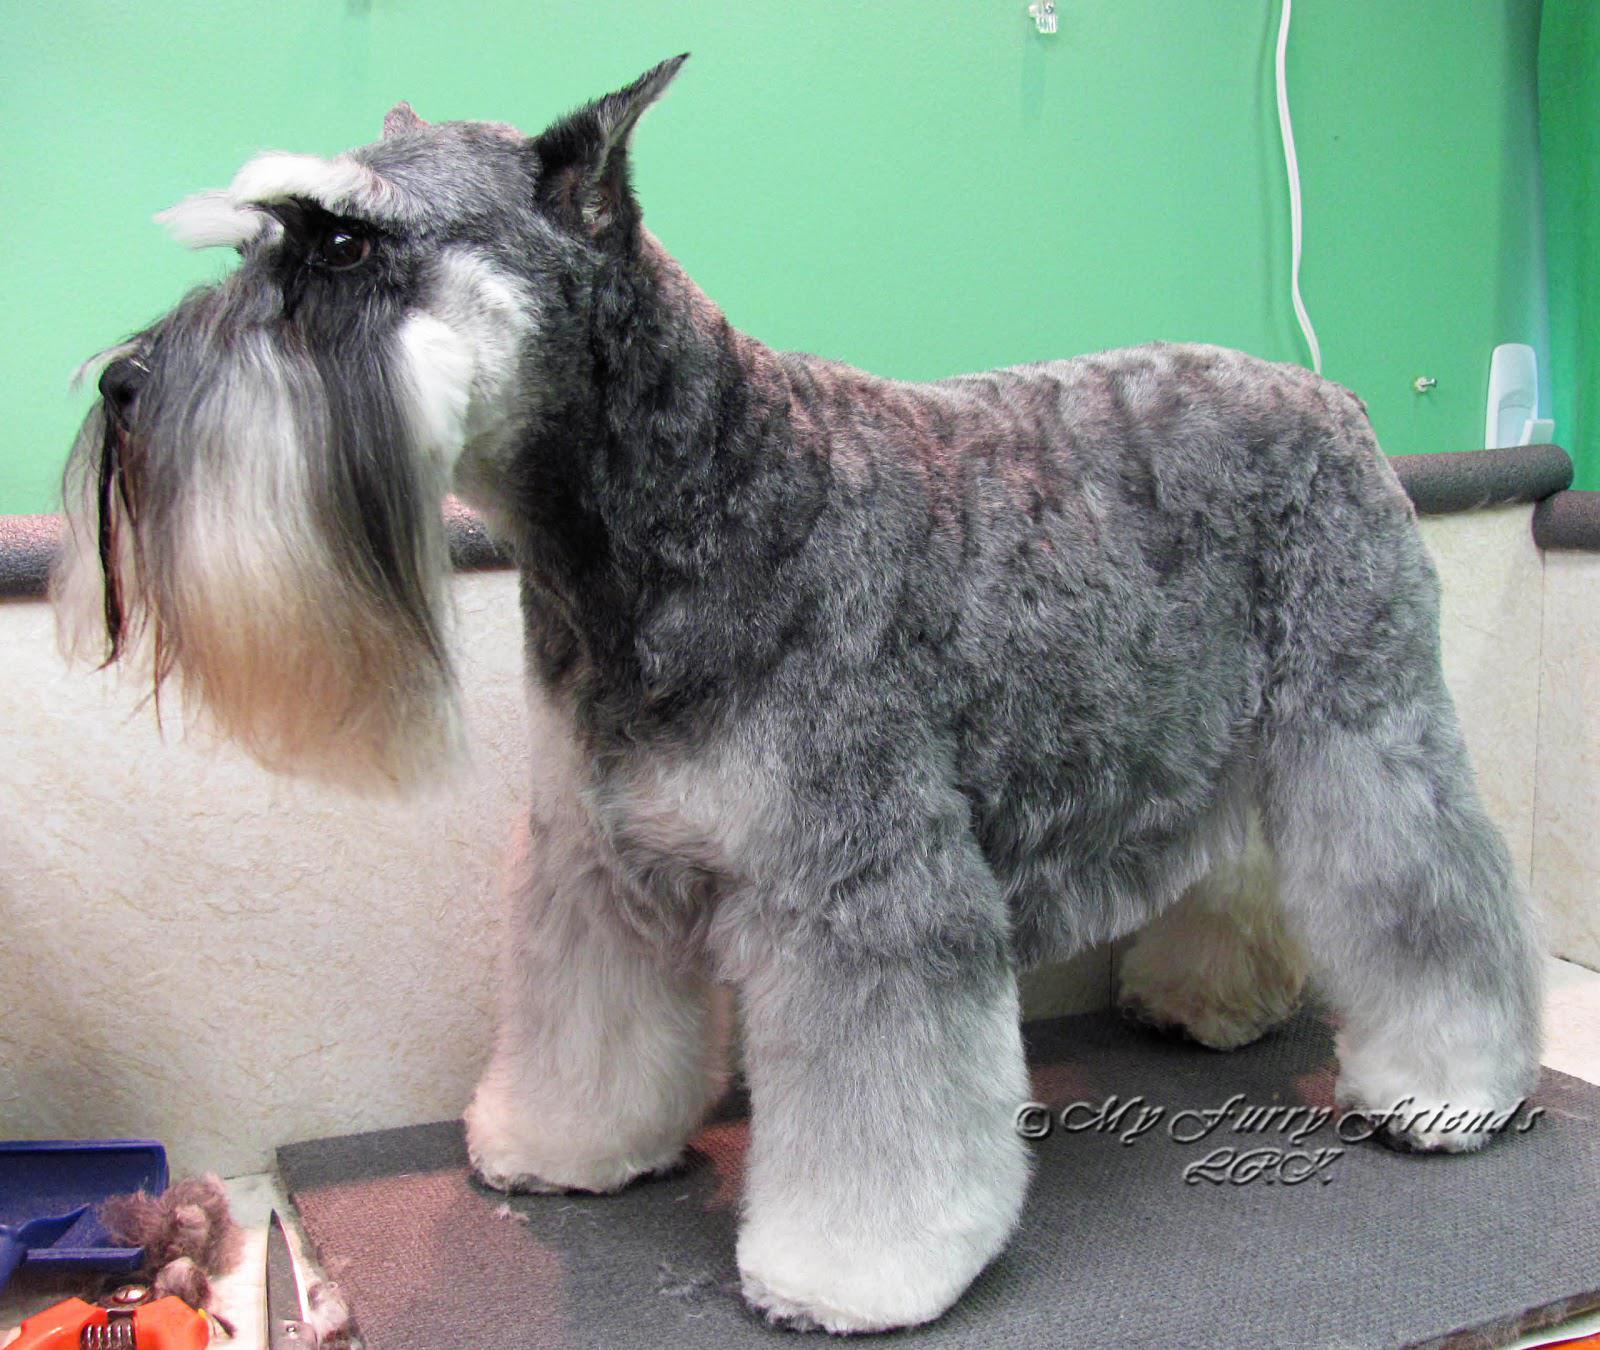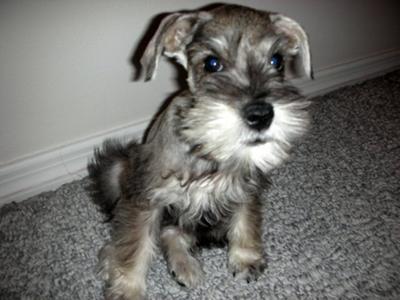The first image is the image on the left, the second image is the image on the right. Evaluate the accuracy of this statement regarding the images: "One of the images contains a dog with only the head showing.". Is it true? Answer yes or no. No. 